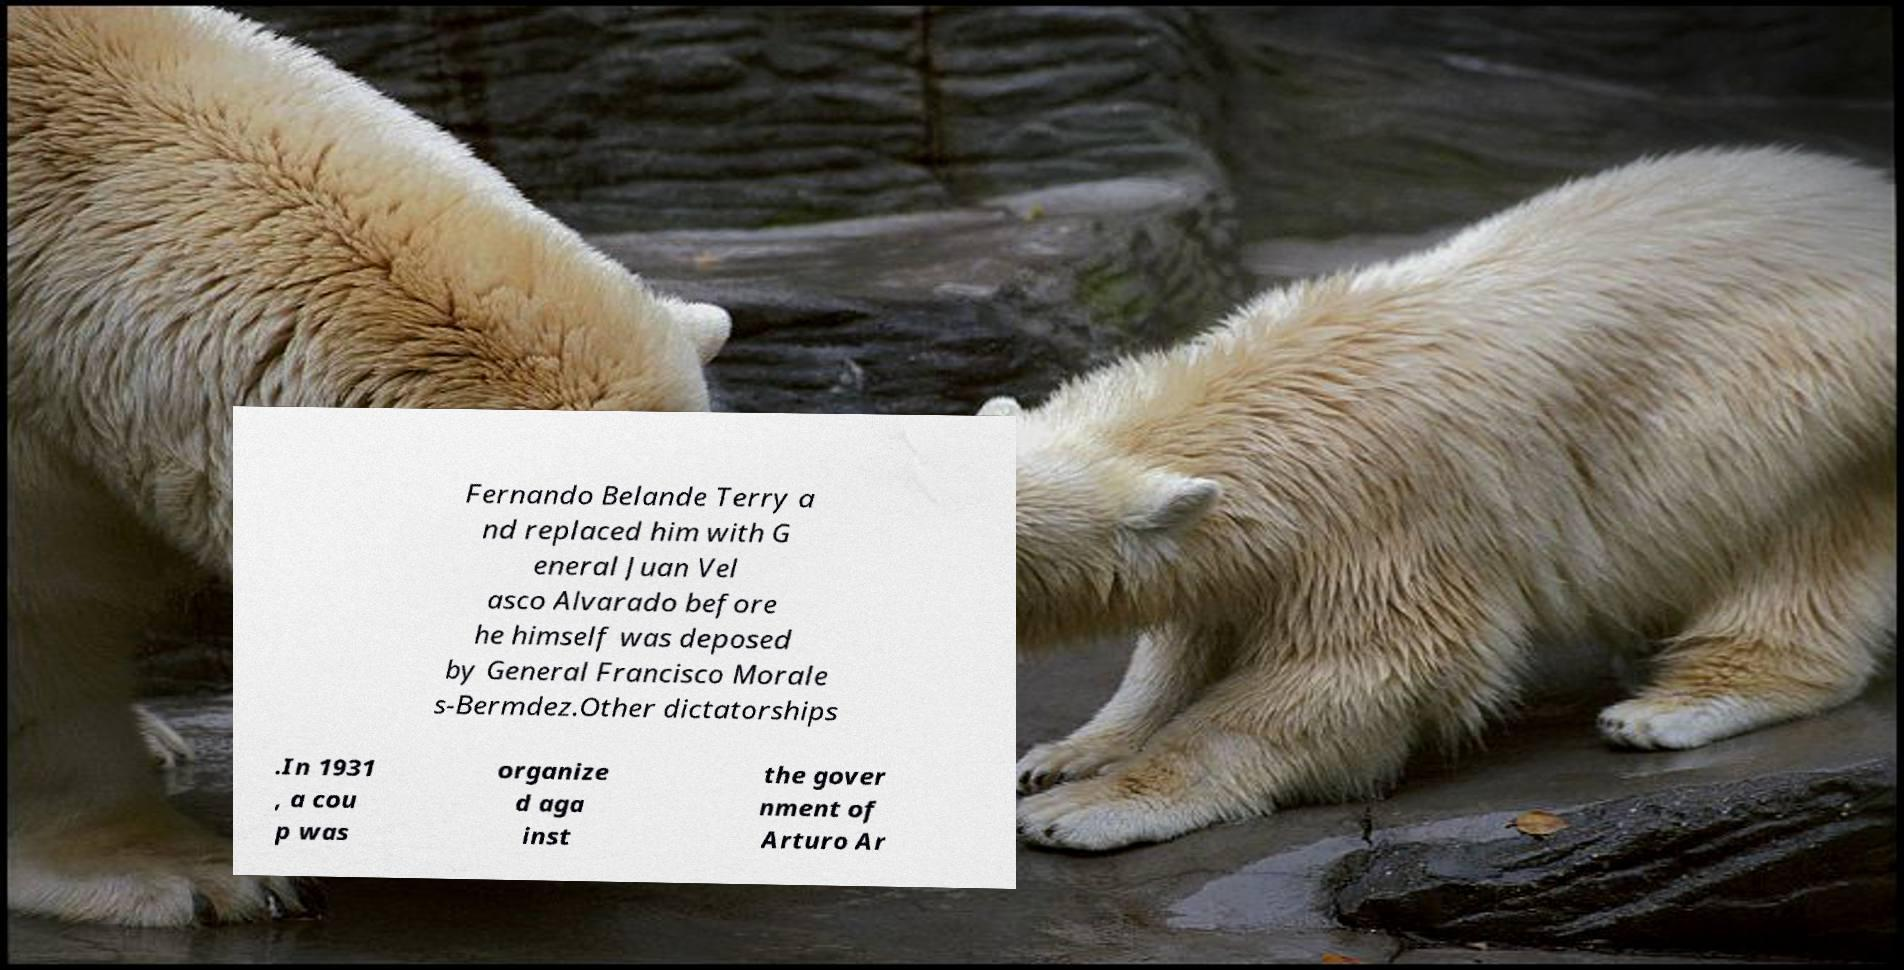For documentation purposes, I need the text within this image transcribed. Could you provide that? Fernando Belande Terry a nd replaced him with G eneral Juan Vel asco Alvarado before he himself was deposed by General Francisco Morale s-Bermdez.Other dictatorships .In 1931 , a cou p was organize d aga inst the gover nment of Arturo Ar 